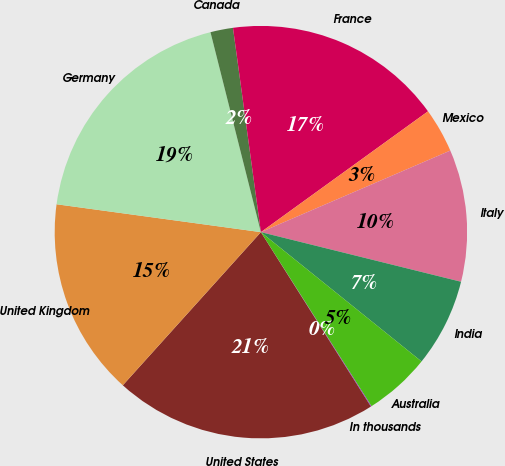Convert chart to OTSL. <chart><loc_0><loc_0><loc_500><loc_500><pie_chart><fcel>In thousands<fcel>United States<fcel>United Kingdom<fcel>Germany<fcel>Canada<fcel>France<fcel>Mexico<fcel>Italy<fcel>India<fcel>Australia<nl><fcel>0.06%<fcel>20.63%<fcel>15.48%<fcel>18.91%<fcel>1.77%<fcel>17.2%<fcel>3.49%<fcel>10.34%<fcel>6.92%<fcel>5.2%<nl></chart> 